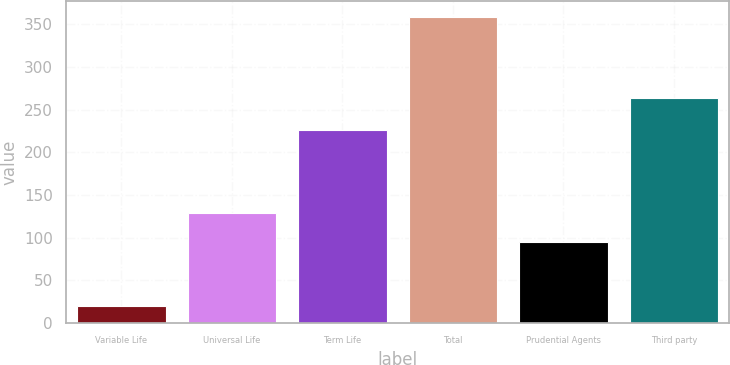<chart> <loc_0><loc_0><loc_500><loc_500><bar_chart><fcel>Variable Life<fcel>Universal Life<fcel>Term Life<fcel>Total<fcel>Prudential Agents<fcel>Third party<nl><fcel>20<fcel>128.9<fcel>226<fcel>359<fcel>95<fcel>264<nl></chart> 